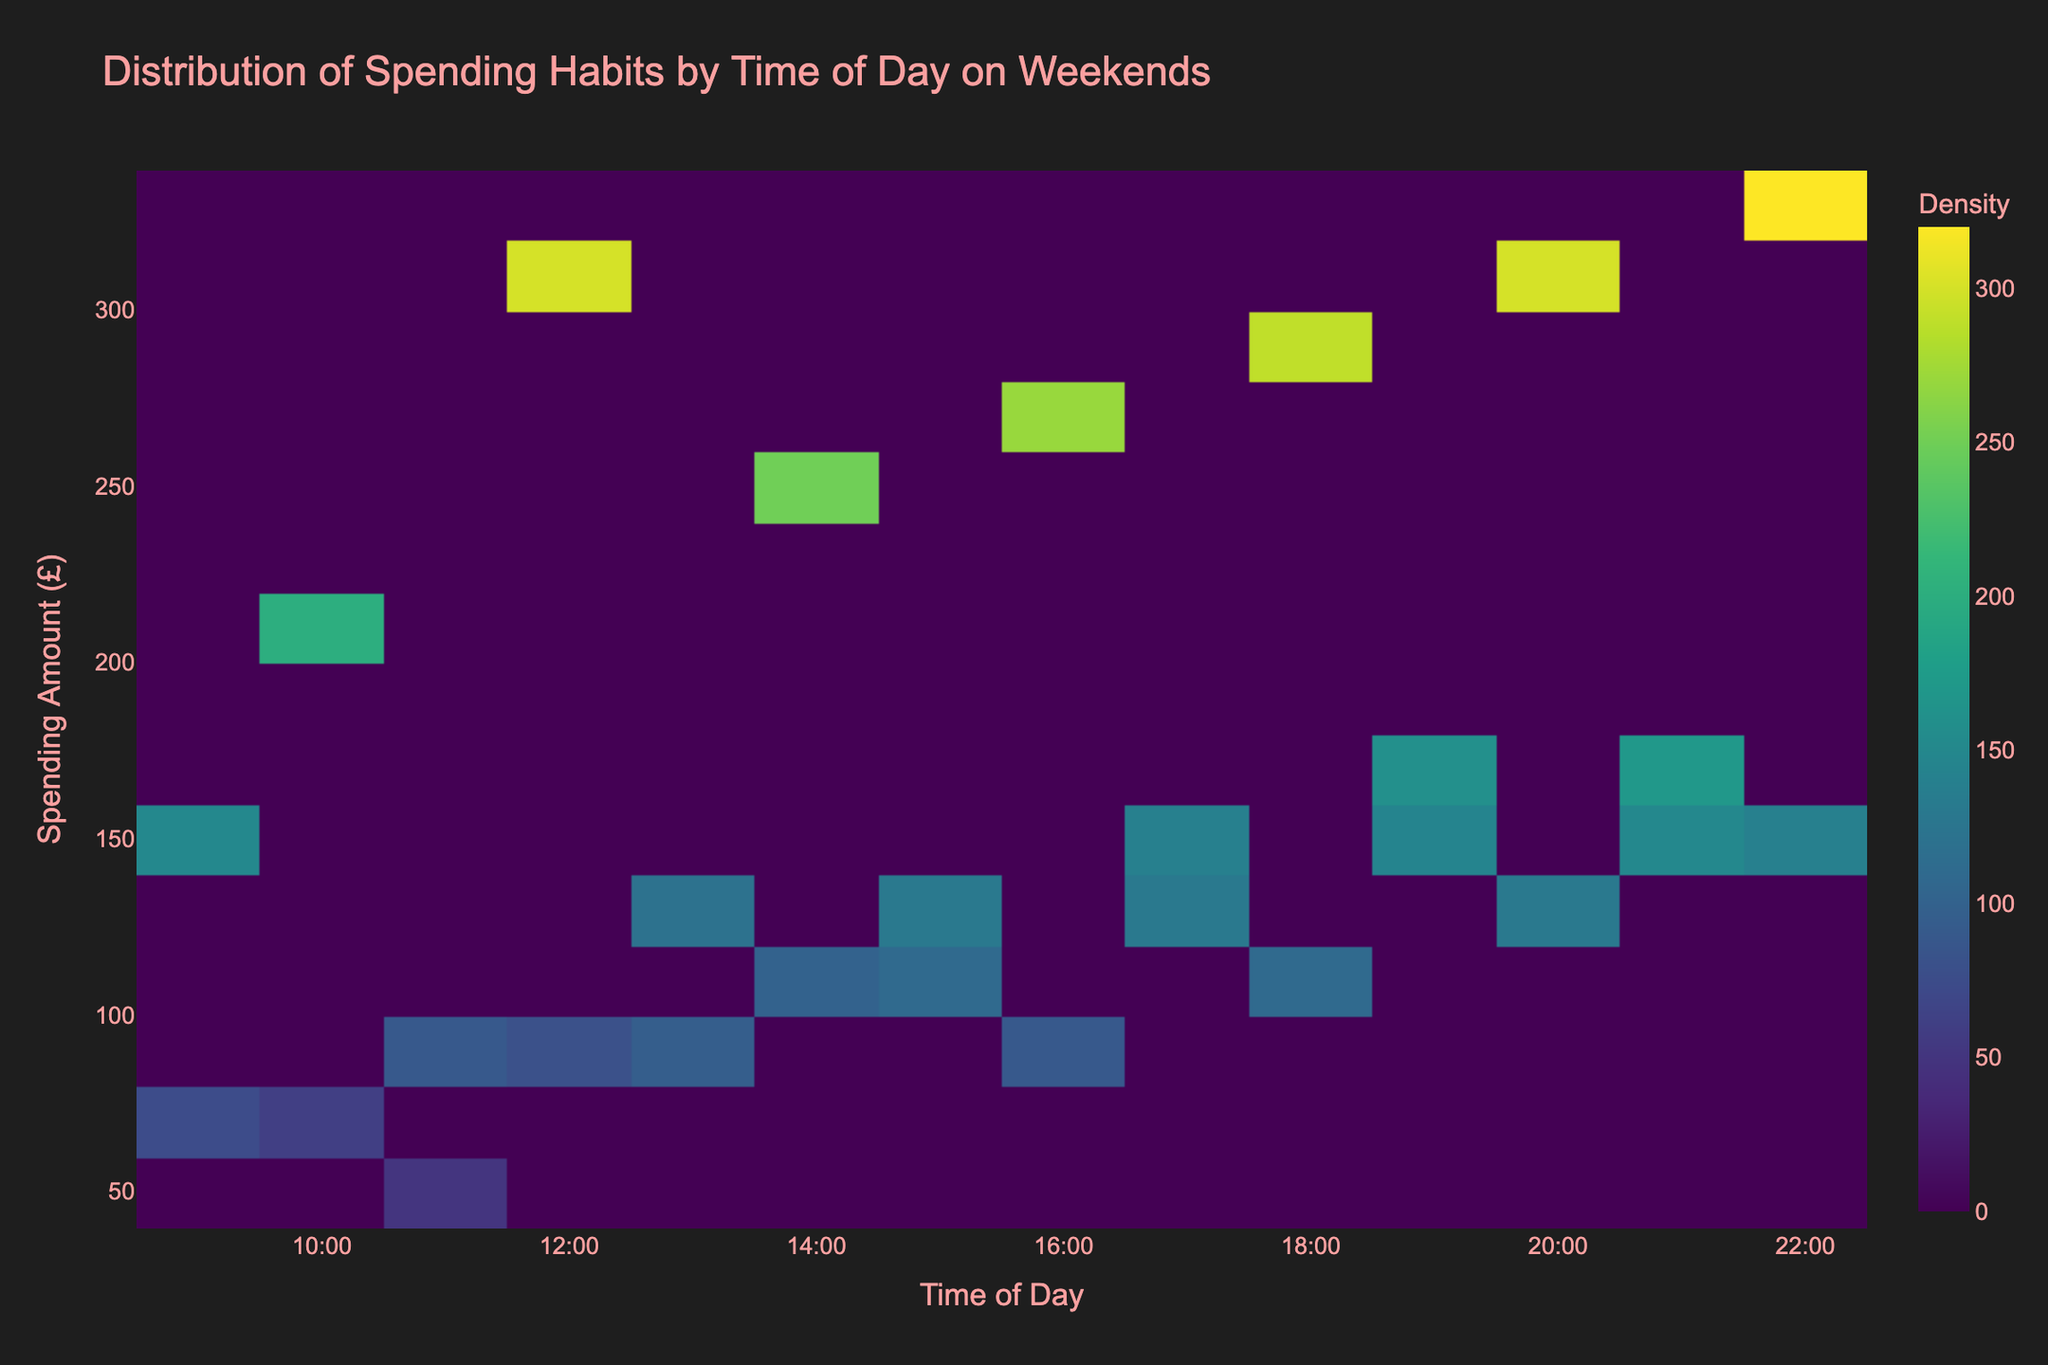What is the title of the plot? The title of the plot is usually prominent and located at the top of the figure.
Answer: Distribution of Spending Habits by Time of Day on Weekends What are the labels on the x-axis and y-axis? The x-axis and y-axis labels are typically positioned along the respective axes to describe what each axis represents.
Answer: Time of Day and Spending Amount (£) What time of day shows the highest density of spending? Identify the time on the x-axis where the plot shows the darkest color, indicating the highest density. This can be usually spotted quickly.
Answer: 22:00 Which category seems to have the highest spending amount on average? Since we are not given categorical information directly in the plot, sum the amounts from the table and divide by the number of observations per category to find the averages. Compute each average: 
   - Food and Beverage: (150+200+300+250+270+290+300+320)/(8) = 2087/8 ≈ 261 
   - Clothing: (75+50+95+110+130+145+150+130)/(8) = 885/8 ≈ 111
   - Electronics: (90+120+130+140+160+170)/(6) = 810/6 = 135
   - Entertainment: (60+80+100+90+110+130+140)/(7) = 710/7≈101 
  From the calculations, Food and Beverage has the highest average spending.
Answer: Food and Beverage What is the average spending amount at 20:00? At 20:00, sum the spending amounts (300 for Food and Beverage and 130 for Entertainment) and then divide by 2 to find the average: (300 + 130)/2 = 430/2 = 215
Answer: 215 At what time does spending on Electronics peak? For finding the peak spending time for a specific category, identify the maximum value in the given data. The highest value for Electronics is 170, which occurs at 21:00, referring directly to the table.
Answer: 21:00 Between what hours does spending appear to be the most diverse (covering a wide range of amounts)? Look for the time range on the plot where the spending amounts vary significantly, usually seen by a broader spread of colors on the y-axis. The range 16:00 to 22:00 has widespread different spending amounts from the figure.
Answer: 16:00 to 22:00 Which hour has the lowest average spending? Calculate the average spending for each hour by summing the amounts from the table and dividing by the count of observations for that hour, then identify the minimum:
- 09:00: (150+75)/2 = 225/2 = 112.5
- 10:00: (60+200)/2 = 260/2 = 130
- 11:00: (90+50)/2 = 140/2 = 70
- 12:00: (300+80)/2 = 380/2 = 190
- 13:00: (95+120)/2 = 215/2 = 107.5
- 14:00: (250+100)/2 = 350/2 = 175
- 15:00: (110+130)/2 = 240/2 = 120
- 16:00: (270+90)/2 = 360/2 = 180
- 17:00: (130+140)/2 = 270/2 = 135
- 18:00: (290+110)/2 = 400/2 = 200
- 19:00: (145+160)/2 = 305/2 = 152.5
- 20:00: (300+130)/2 = 430/2 = 215
- 21:00: (150+170)/2 = 320/2 = 160
- 22:00: (320+140)/2 = 460/2 = 230
From these, the hour 11:00 has the lowest average spending of 70.
Answer: 11:00 